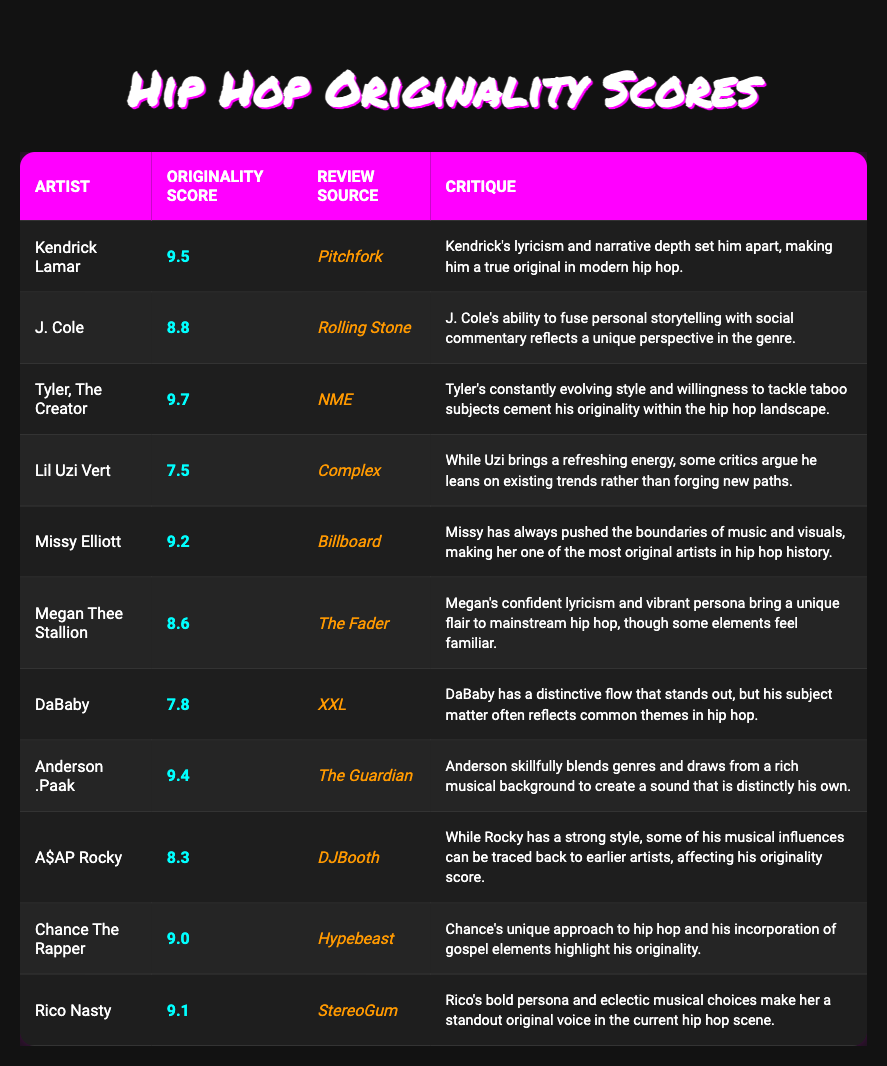What is the highest originality score and which artist received it? The highest originality score in the table is 9.7, and it was awarded to Tyler, The Creator. I found this by scanning the "Originality Score" column and identifying the maximum value.
Answer: 9.7, Tyler, The Creator How many artists have an originality score above 9.0? There are 5 artists with originality scores above 9.0. They are Kendrick Lamar (9.5), Tyler, The Creator (9.7), Missy Elliott (9.2), Anderson .Paak (9.4), and Rico Nasty (9.1). Counting these listed entries gives the total.
Answer: 5 Is it true that DaBaby has an originality score of 8.0 or higher? Yes, it is true. DaBaby's originality score is 7.8, which is less than 8.0. This can be verified by checking the "Originality Score" for DaBaby in the table.
Answer: No Calculate the average originality score of the artists listed in the table. To find the average, I first sum all the originality scores: (9.5 + 8.8 + 9.7 + 7.5 + 9.2 + 8.6 + 7.8 + 9.4 + 8.3 + 9.0 + 9.1) = 101.9. There are 11 artists in total, so I divide the sum by 11: 101.9 / 11 = 9.244.
Answer: 9.24 Who has a lower originality score, A$AP Rocky or J. Cole? A$AP Rocky has an originality score of 8.3 while J. Cole has a score of 8.8. Since 8.3 is less than 8.8, this means A$AP Rocky has the lower score.
Answer: A$AP Rocky Which artist's originality score is closest to 8.5? Megan Thee Stallion has an originality score of 8.6, which is the closest to 8.5 when reviewing the scores in the table. I compared each score to 8.5 to find the nearest.
Answer: Megan Thee Stallion What is the review source for Kendrick Lamar's originality score and what did they say? Kendrick Lamar's originality score is reviewed by Pitchfork. The critique mentions that "Kendrick's lyricism and narrative depth set him apart, making him a true original in modern hip hop." This is found directly in the "Review Source" and "Critique" columns for Kendrick Lamar.
Answer: Pitchfork, "Kendrick's lyricism and narrative depth set him apart, making him a true original in modern hip hop." Are there more artists with scores below 8.0 than above? No, there are not more artists below 8.0. Only DaBaby (7.8) and Lil Uzi Vert (7.5) have scores below 8.0, while there are 9 artists with scores above 8.0. Counting each group confirms this.
Answer: No 